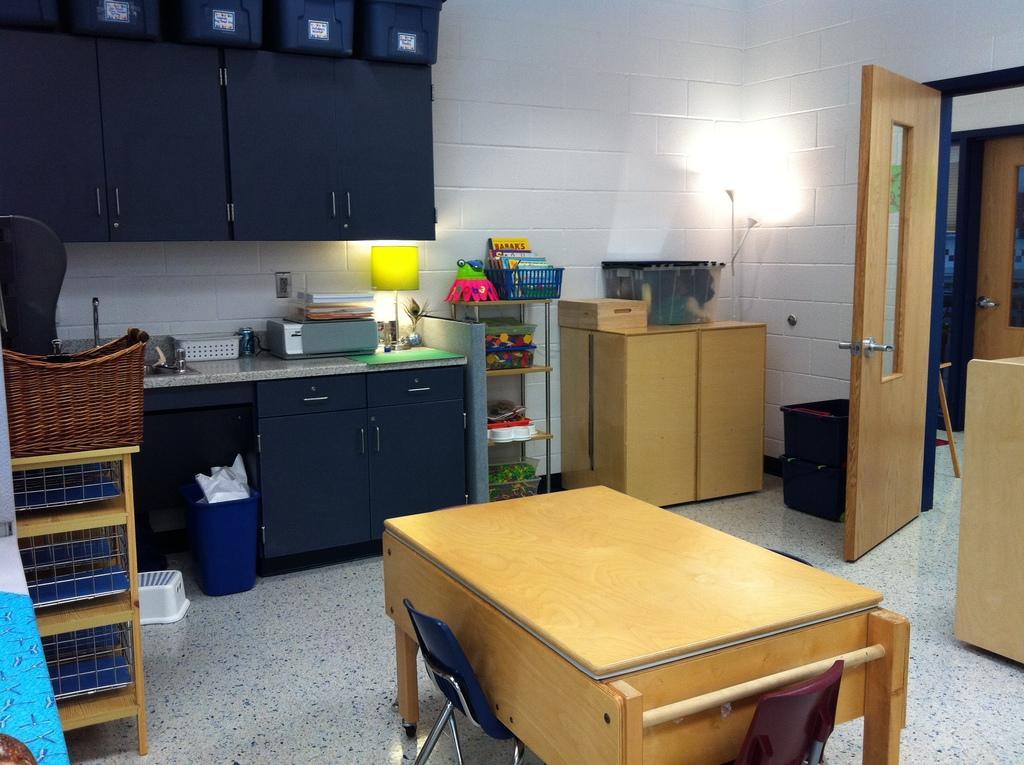In one or two sentences, can you explain what this image depicts? These image is taken inside a room. In the center of the image there is a table. There is a platform on which there are many objects. There is a door. In the background of the image there is a wall. There are cupboards. 